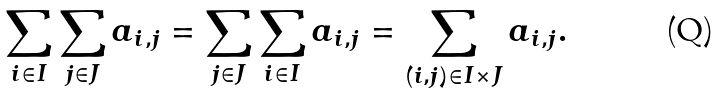Convert formula to latex. <formula><loc_0><loc_0><loc_500><loc_500>\sum _ { i \in I } \sum _ { j \in J } a _ { i , j } = \sum _ { j \in J } \sum _ { i \in I } a _ { i , j } = \sum _ { ( i , j ) \in I \times J } a _ { i , j } .</formula> 